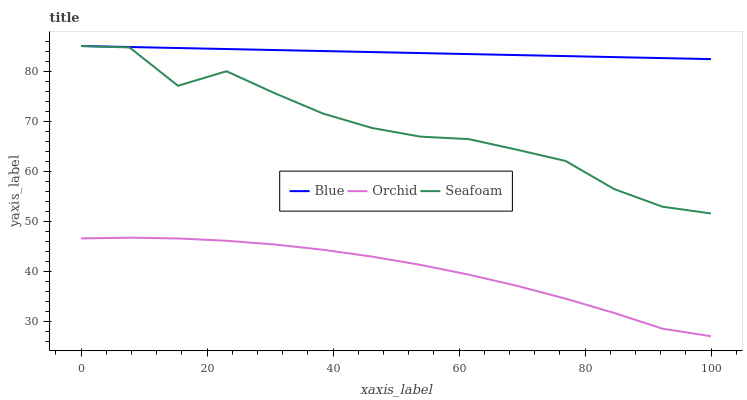Does Orchid have the minimum area under the curve?
Answer yes or no. Yes. Does Blue have the maximum area under the curve?
Answer yes or no. Yes. Does Seafoam have the minimum area under the curve?
Answer yes or no. No. Does Seafoam have the maximum area under the curve?
Answer yes or no. No. Is Blue the smoothest?
Answer yes or no. Yes. Is Seafoam the roughest?
Answer yes or no. Yes. Is Orchid the smoothest?
Answer yes or no. No. Is Orchid the roughest?
Answer yes or no. No. Does Orchid have the lowest value?
Answer yes or no. Yes. Does Seafoam have the lowest value?
Answer yes or no. No. Does Seafoam have the highest value?
Answer yes or no. Yes. Does Orchid have the highest value?
Answer yes or no. No. Is Orchid less than Seafoam?
Answer yes or no. Yes. Is Blue greater than Orchid?
Answer yes or no. Yes. Does Blue intersect Seafoam?
Answer yes or no. Yes. Is Blue less than Seafoam?
Answer yes or no. No. Is Blue greater than Seafoam?
Answer yes or no. No. Does Orchid intersect Seafoam?
Answer yes or no. No. 